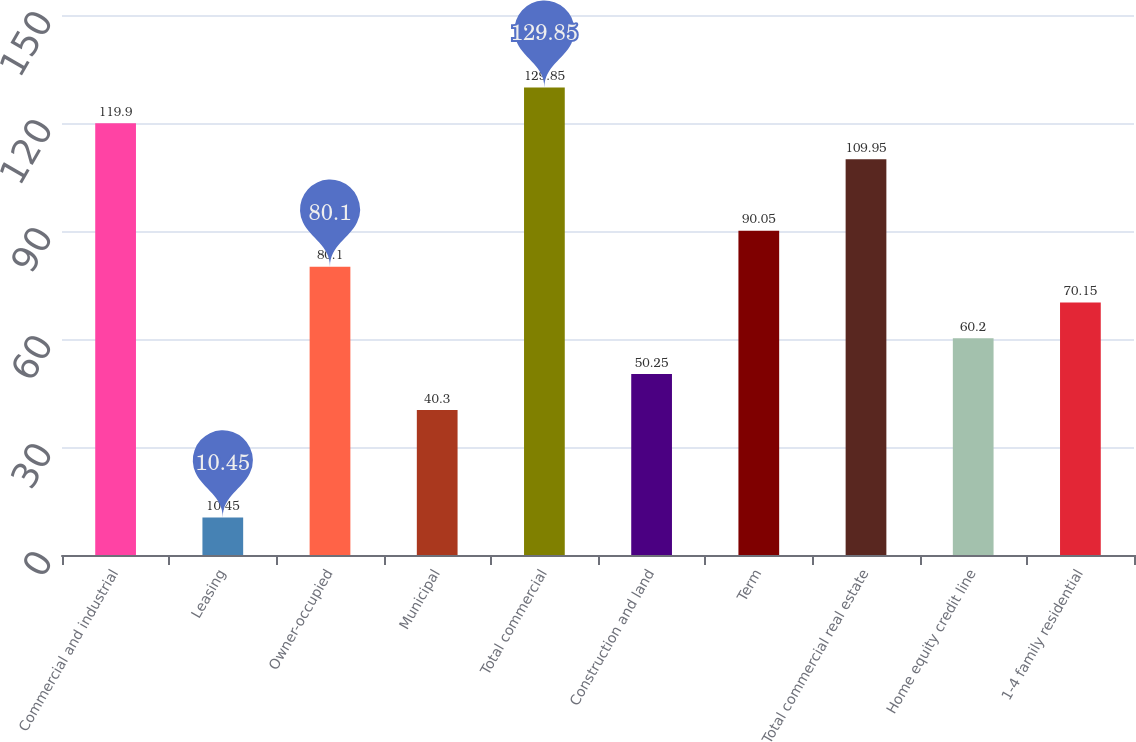<chart> <loc_0><loc_0><loc_500><loc_500><bar_chart><fcel>Commercial and industrial<fcel>Leasing<fcel>Owner-occupied<fcel>Municipal<fcel>Total commercial<fcel>Construction and land<fcel>Term<fcel>Total commercial real estate<fcel>Home equity credit line<fcel>1-4 family residential<nl><fcel>119.9<fcel>10.45<fcel>80.1<fcel>40.3<fcel>129.85<fcel>50.25<fcel>90.05<fcel>109.95<fcel>60.2<fcel>70.15<nl></chart> 